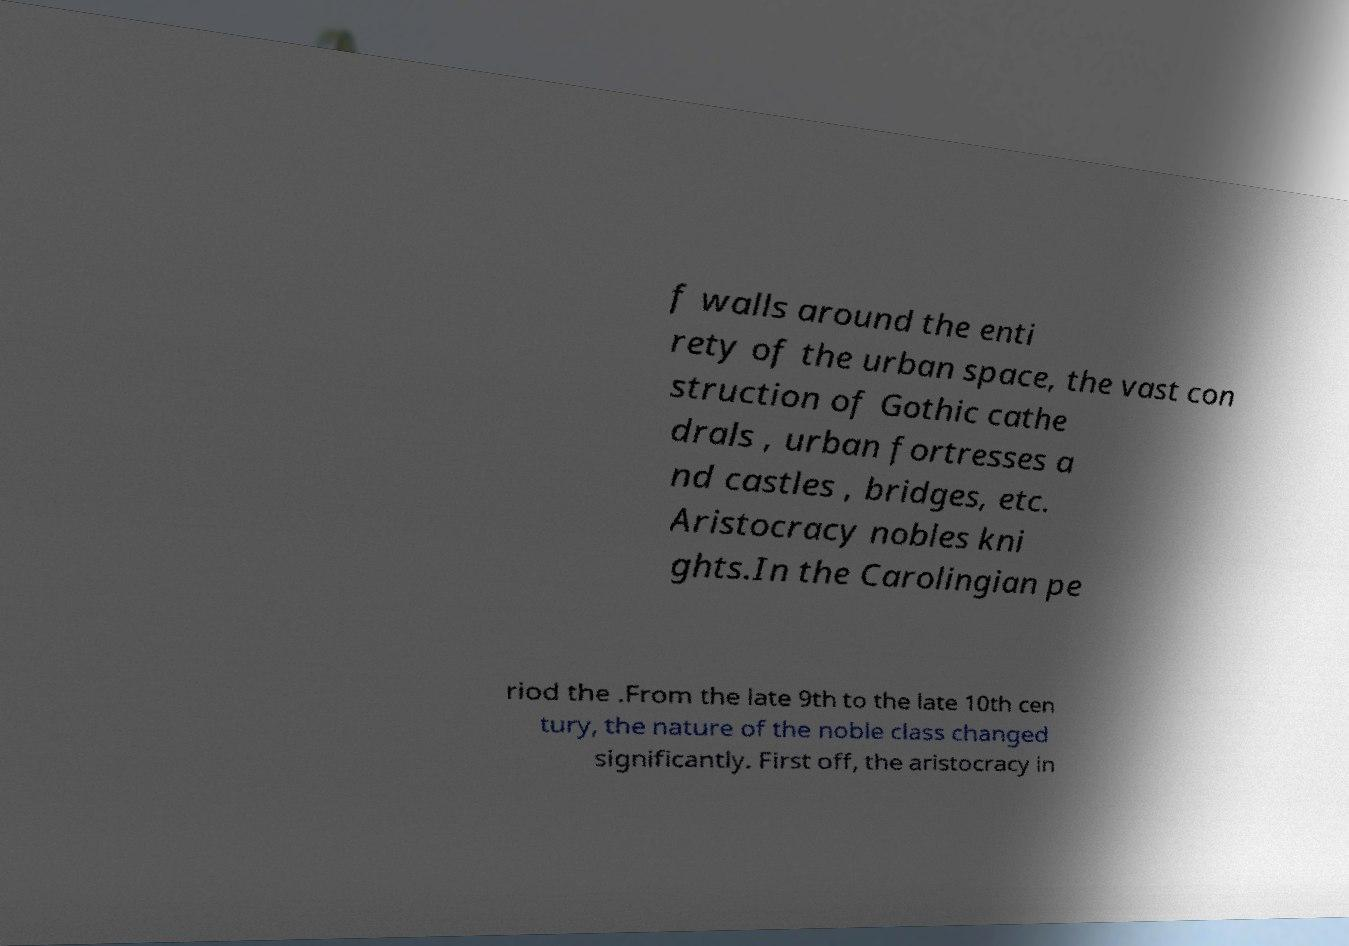What messages or text are displayed in this image? I need them in a readable, typed format. f walls around the enti rety of the urban space, the vast con struction of Gothic cathe drals , urban fortresses a nd castles , bridges, etc. Aristocracy nobles kni ghts.In the Carolingian pe riod the .From the late 9th to the late 10th cen tury, the nature of the noble class changed significantly. First off, the aristocracy in 